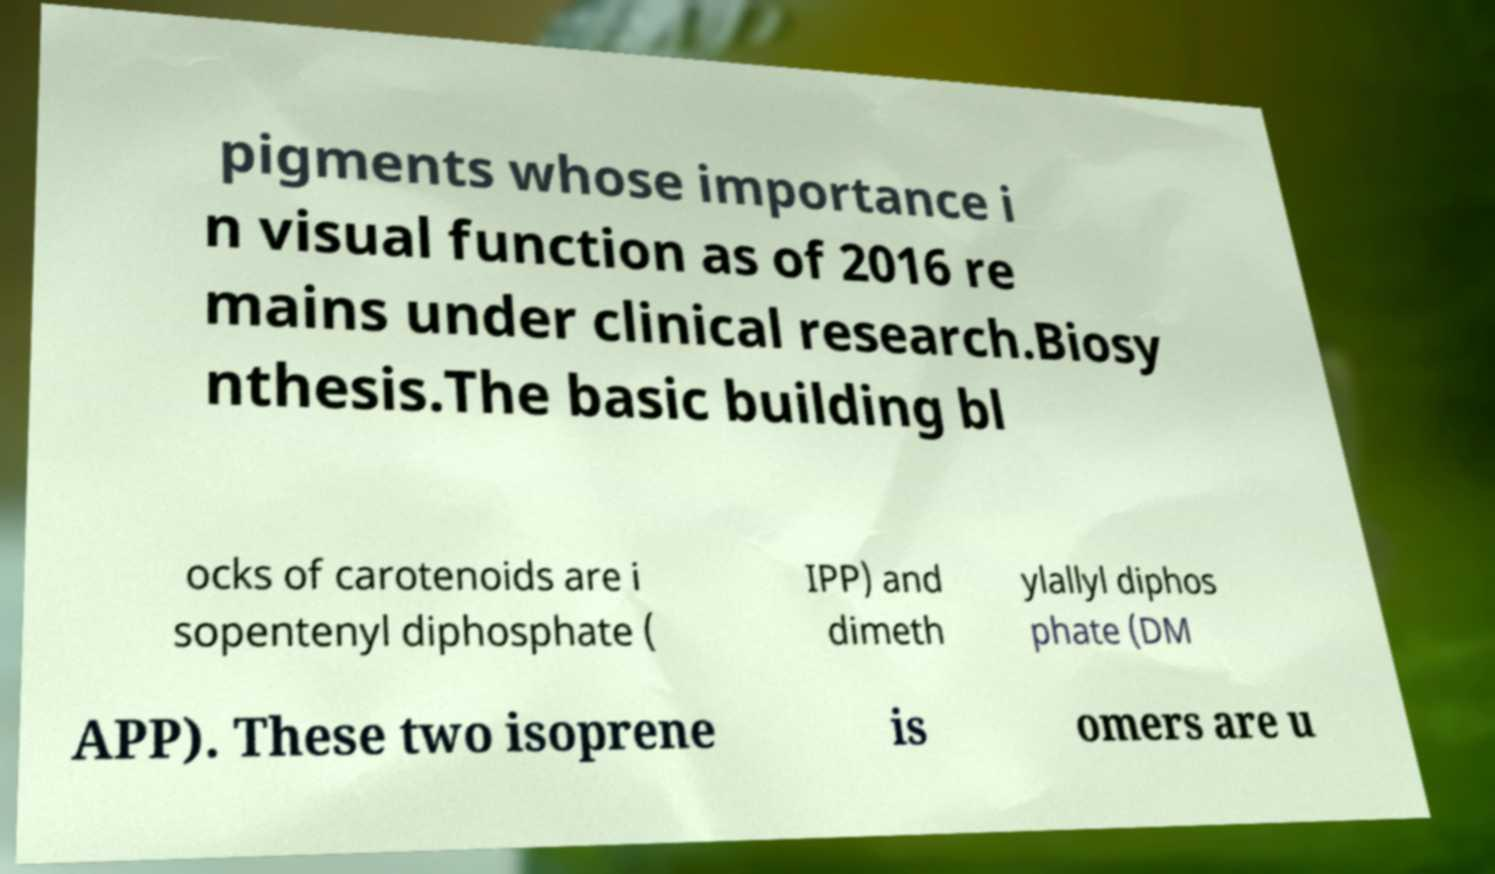What messages or text are displayed in this image? I need them in a readable, typed format. pigments whose importance i n visual function as of 2016 re mains under clinical research.Biosy nthesis.The basic building bl ocks of carotenoids are i sopentenyl diphosphate ( IPP) and dimeth ylallyl diphos phate (DM APP). These two isoprene is omers are u 